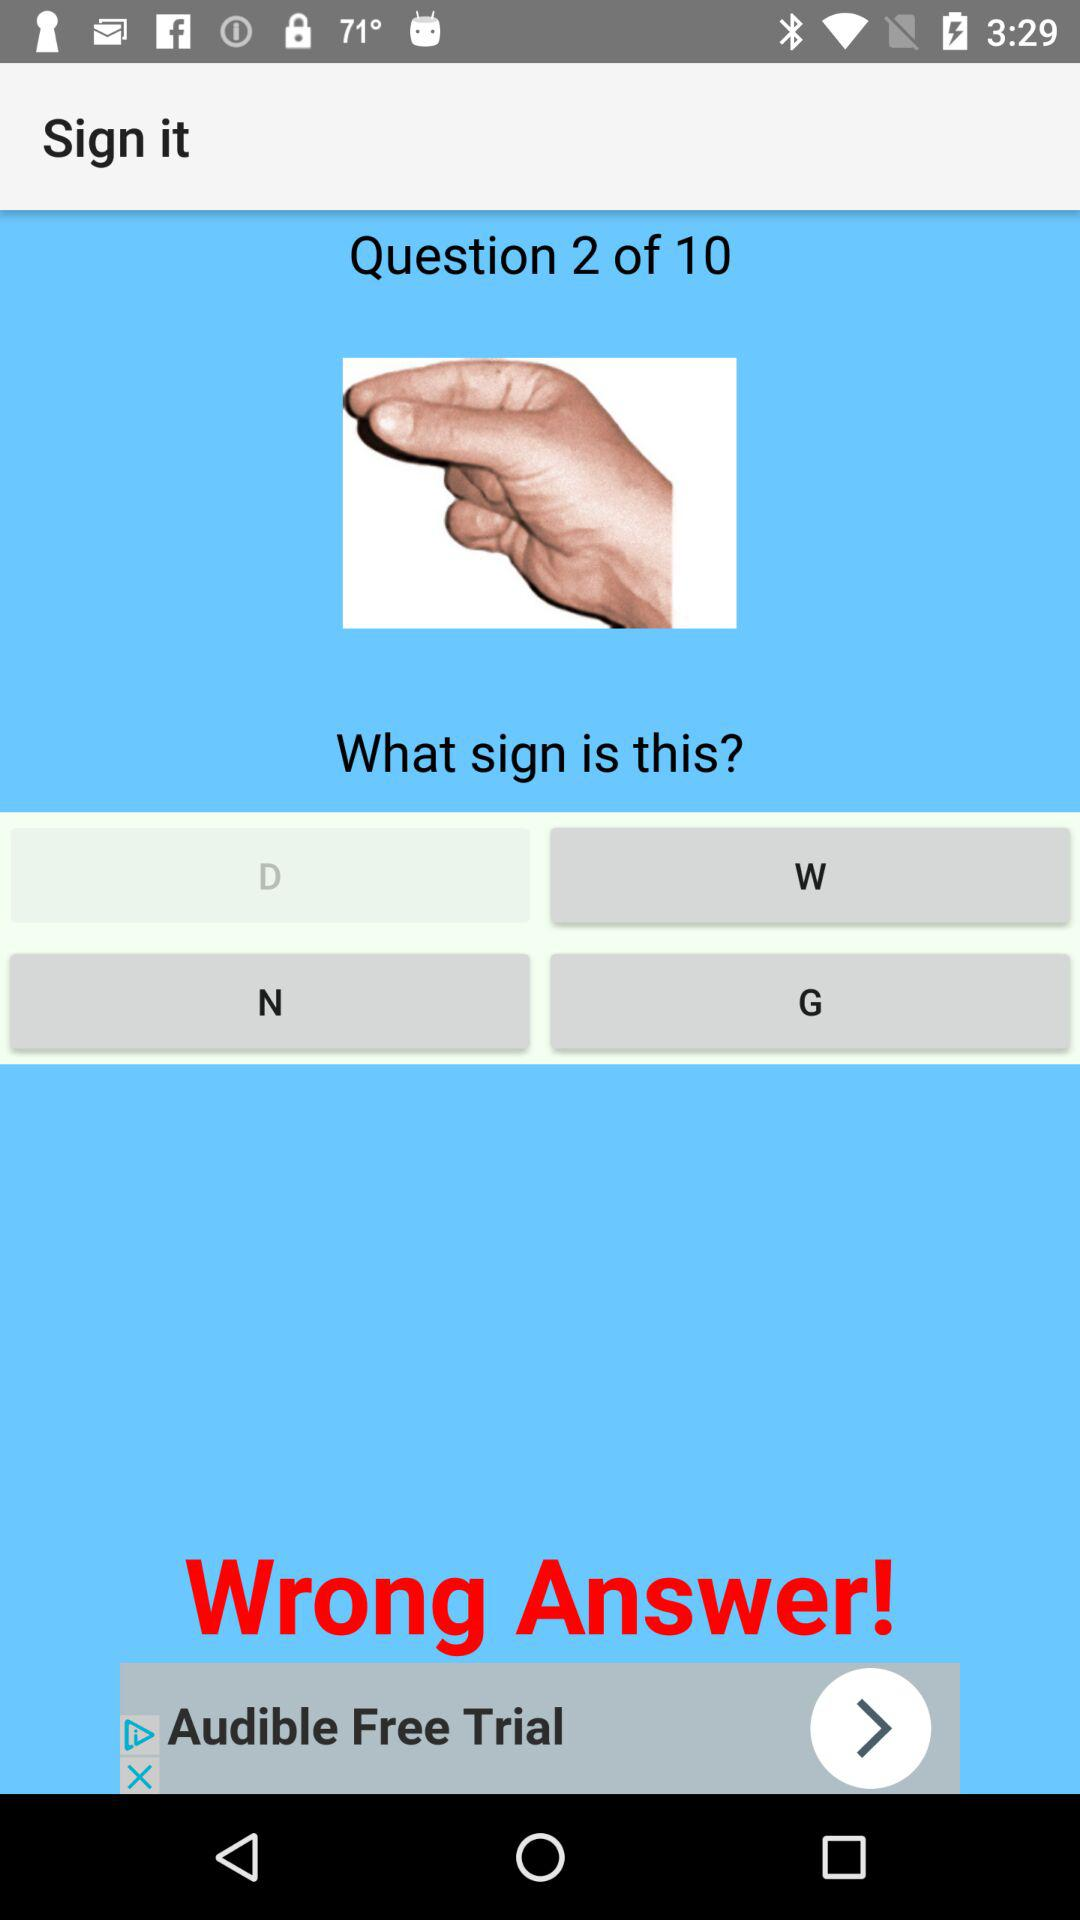Which is the current question number? The current question number is 2. 